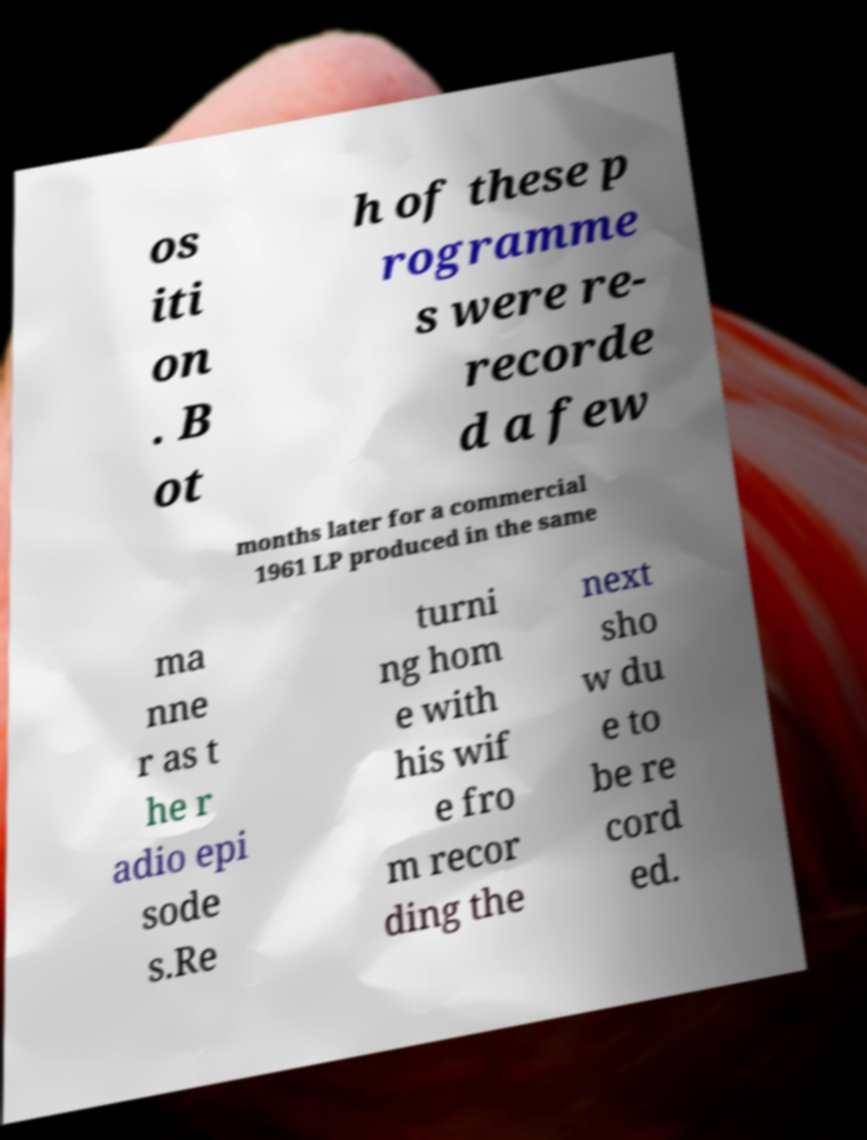Please identify and transcribe the text found in this image. os iti on . B ot h of these p rogramme s were re- recorde d a few months later for a commercial 1961 LP produced in the same ma nne r as t he r adio epi sode s.Re turni ng hom e with his wif e fro m recor ding the next sho w du e to be re cord ed. 